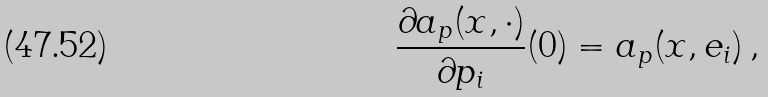Convert formula to latex. <formula><loc_0><loc_0><loc_500><loc_500>\frac { \partial a _ { p } ( x , \cdot ) } { \partial p _ { i } } ( 0 ) = a _ { p } ( x , e _ { i } ) \, ,</formula> 